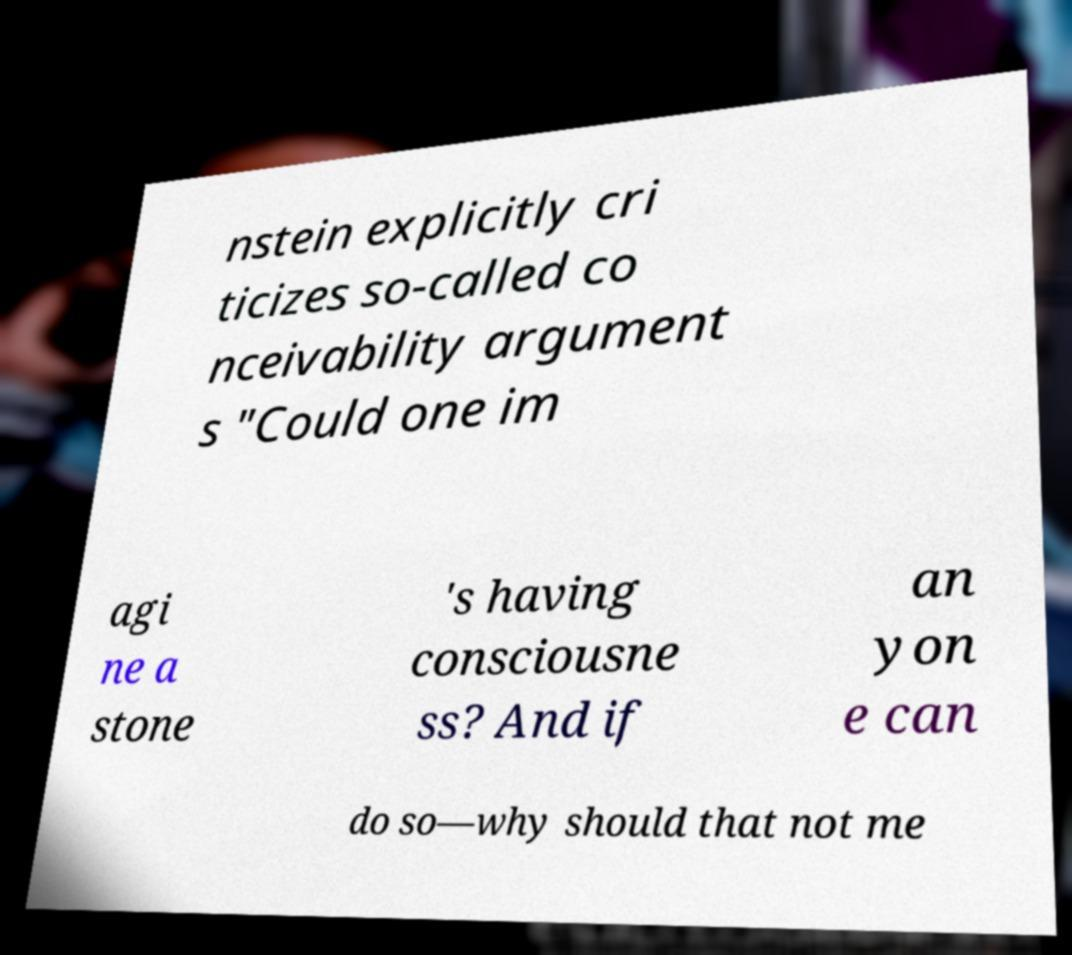There's text embedded in this image that I need extracted. Can you transcribe it verbatim? nstein explicitly cri ticizes so-called co nceivability argument s "Could one im agi ne a stone 's having consciousne ss? And if an yon e can do so—why should that not me 